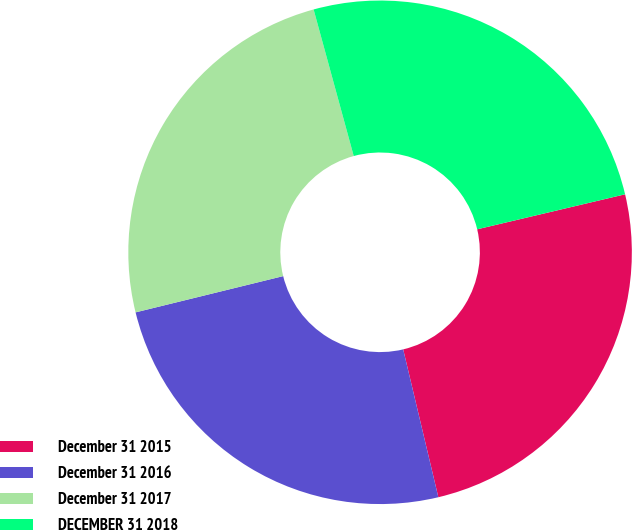<chart> <loc_0><loc_0><loc_500><loc_500><pie_chart><fcel>December 31 2015<fcel>December 31 2016<fcel>December 31 2017<fcel>DECEMBER 31 2018<nl><fcel>24.98%<fcel>24.88%<fcel>24.58%<fcel>25.55%<nl></chart> 